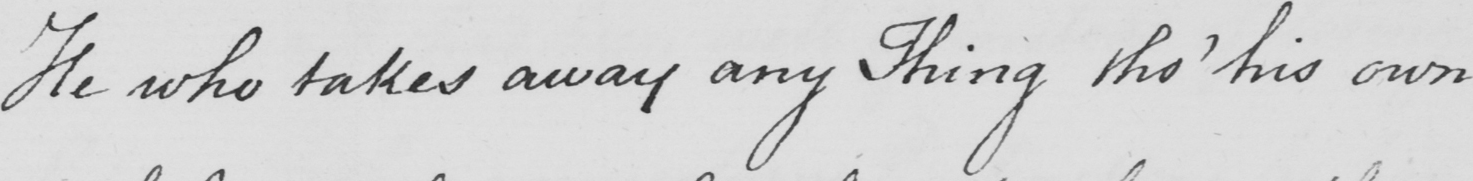What does this handwritten line say? He who takes away a Thing tho '  his own 